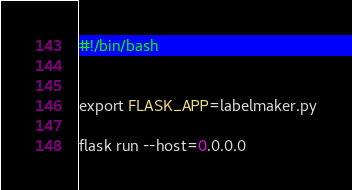Convert code to text. <code><loc_0><loc_0><loc_500><loc_500><_Bash_>#!/bin/bash


export FLASK_APP=labelmaker.py

flask run --host=0.0.0.0
</code> 